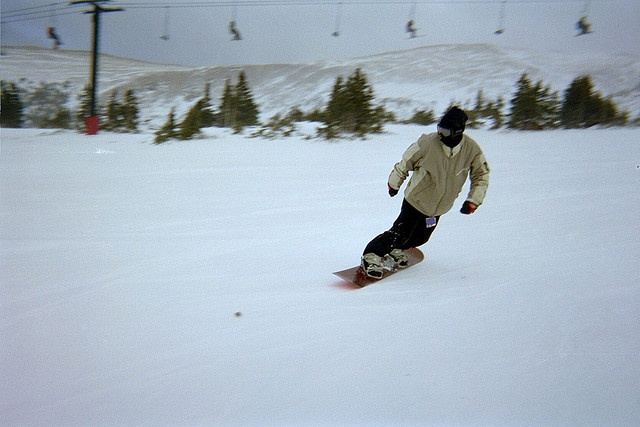Describe the objects in this image and their specific colors. I can see people in darkgray, gray, black, and darkgreen tones and snowboard in darkgray, gray, black, and maroon tones in this image. 